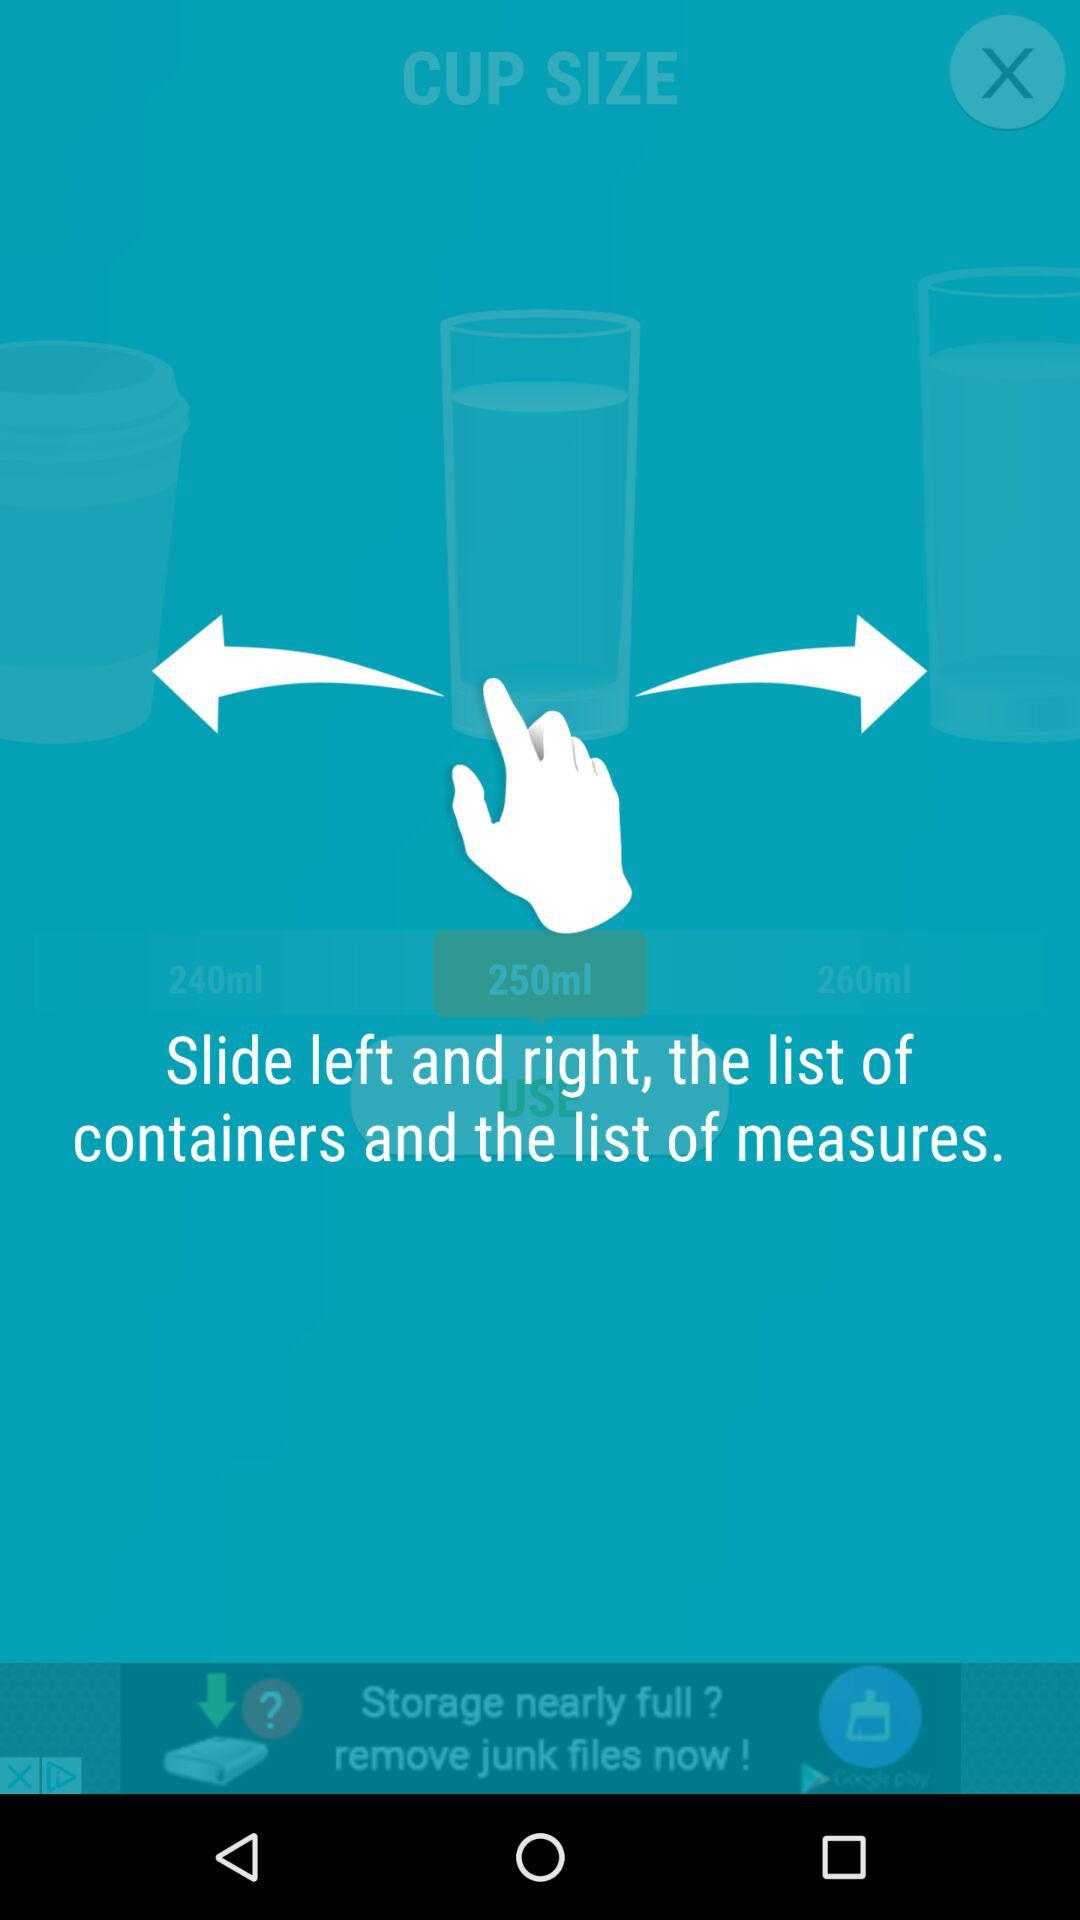How many ml is the largest cup size?
Answer the question using a single word or phrase. 260ml 